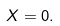Convert formula to latex. <formula><loc_0><loc_0><loc_500><loc_500>X = 0 .</formula> 